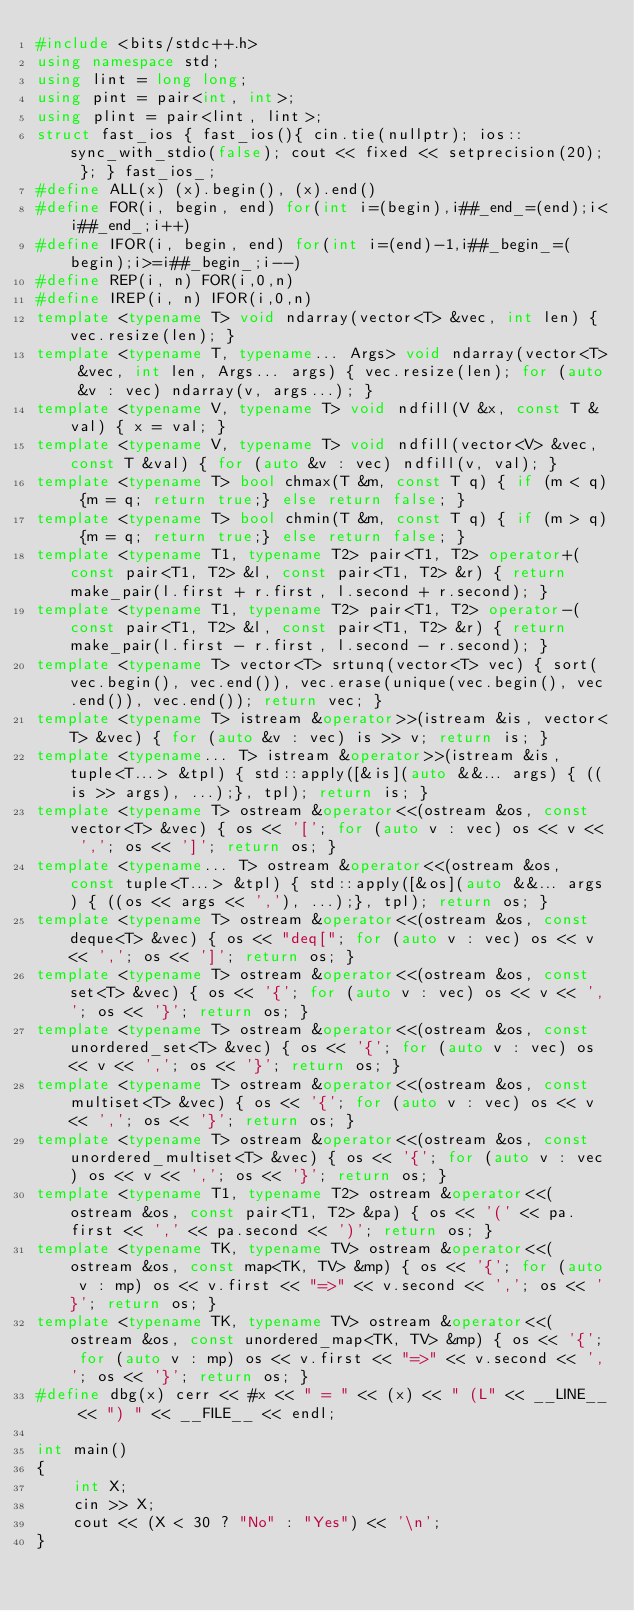<code> <loc_0><loc_0><loc_500><loc_500><_C++_>#include <bits/stdc++.h>
using namespace std;
using lint = long long;
using pint = pair<int, int>;
using plint = pair<lint, lint>;
struct fast_ios { fast_ios(){ cin.tie(nullptr); ios::sync_with_stdio(false); cout << fixed << setprecision(20); }; } fast_ios_;
#define ALL(x) (x).begin(), (x).end()
#define FOR(i, begin, end) for(int i=(begin),i##_end_=(end);i<i##_end_;i++)
#define IFOR(i, begin, end) for(int i=(end)-1,i##_begin_=(begin);i>=i##_begin_;i--)
#define REP(i, n) FOR(i,0,n)
#define IREP(i, n) IFOR(i,0,n)
template <typename T> void ndarray(vector<T> &vec, int len) { vec.resize(len); }
template <typename T, typename... Args> void ndarray(vector<T> &vec, int len, Args... args) { vec.resize(len); for (auto &v : vec) ndarray(v, args...); }
template <typename V, typename T> void ndfill(V &x, const T &val) { x = val; }
template <typename V, typename T> void ndfill(vector<V> &vec, const T &val) { for (auto &v : vec) ndfill(v, val); }
template <typename T> bool chmax(T &m, const T q) { if (m < q) {m = q; return true;} else return false; }
template <typename T> bool chmin(T &m, const T q) { if (m > q) {m = q; return true;} else return false; }
template <typename T1, typename T2> pair<T1, T2> operator+(const pair<T1, T2> &l, const pair<T1, T2> &r) { return make_pair(l.first + r.first, l.second + r.second); }
template <typename T1, typename T2> pair<T1, T2> operator-(const pair<T1, T2> &l, const pair<T1, T2> &r) { return make_pair(l.first - r.first, l.second - r.second); }
template <typename T> vector<T> srtunq(vector<T> vec) { sort(vec.begin(), vec.end()), vec.erase(unique(vec.begin(), vec.end()), vec.end()); return vec; }
template <typename T> istream &operator>>(istream &is, vector<T> &vec) { for (auto &v : vec) is >> v; return is; }
template <typename... T> istream &operator>>(istream &is, tuple<T...> &tpl) { std::apply([&is](auto &&... args) { ((is >> args), ...);}, tpl); return is; }
template <typename T> ostream &operator<<(ostream &os, const vector<T> &vec) { os << '['; for (auto v : vec) os << v << ','; os << ']'; return os; }
template <typename... T> ostream &operator<<(ostream &os, const tuple<T...> &tpl) { std::apply([&os](auto &&... args) { ((os << args << ','), ...);}, tpl); return os; }
template <typename T> ostream &operator<<(ostream &os, const deque<T> &vec) { os << "deq["; for (auto v : vec) os << v << ','; os << ']'; return os; }
template <typename T> ostream &operator<<(ostream &os, const set<T> &vec) { os << '{'; for (auto v : vec) os << v << ','; os << '}'; return os; }
template <typename T> ostream &operator<<(ostream &os, const unordered_set<T> &vec) { os << '{'; for (auto v : vec) os << v << ','; os << '}'; return os; }
template <typename T> ostream &operator<<(ostream &os, const multiset<T> &vec) { os << '{'; for (auto v : vec) os << v << ','; os << '}'; return os; }
template <typename T> ostream &operator<<(ostream &os, const unordered_multiset<T> &vec) { os << '{'; for (auto v : vec) os << v << ','; os << '}'; return os; }
template <typename T1, typename T2> ostream &operator<<(ostream &os, const pair<T1, T2> &pa) { os << '(' << pa.first << ',' << pa.second << ')'; return os; }
template <typename TK, typename TV> ostream &operator<<(ostream &os, const map<TK, TV> &mp) { os << '{'; for (auto v : mp) os << v.first << "=>" << v.second << ','; os << '}'; return os; }
template <typename TK, typename TV> ostream &operator<<(ostream &os, const unordered_map<TK, TV> &mp) { os << '{'; for (auto v : mp) os << v.first << "=>" << v.second << ','; os << '}'; return os; }
#define dbg(x) cerr << #x << " = " << (x) << " (L" << __LINE__ << ") " << __FILE__ << endl;

int main()
{
    int X;
    cin >> X;
    cout << (X < 30 ? "No" : "Yes") << '\n';
}
</code> 